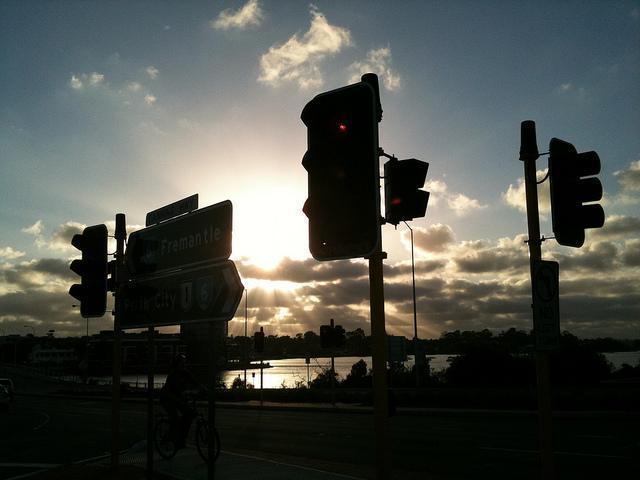How many traffic lights can you see?
Give a very brief answer. 3. How many boats are there?
Give a very brief answer. 0. 